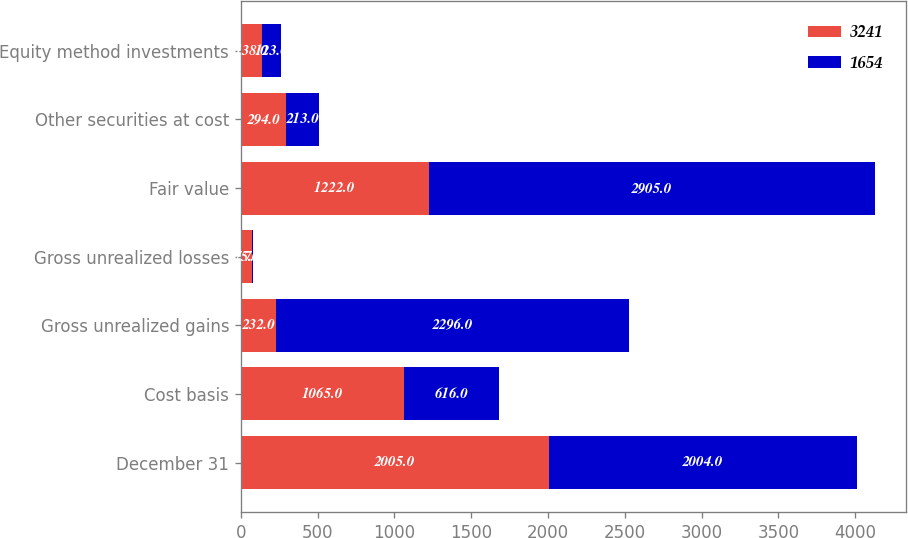Convert chart to OTSL. <chart><loc_0><loc_0><loc_500><loc_500><stacked_bar_chart><ecel><fcel>December 31<fcel>Cost basis<fcel>Gross unrealized gains<fcel>Gross unrealized losses<fcel>Fair value<fcel>Other securities at cost<fcel>Equity method investments<nl><fcel>3241<fcel>2005<fcel>1065<fcel>232<fcel>75<fcel>1222<fcel>294<fcel>138<nl><fcel>1654<fcel>2004<fcel>616<fcel>2296<fcel>7<fcel>2905<fcel>213<fcel>123<nl></chart> 